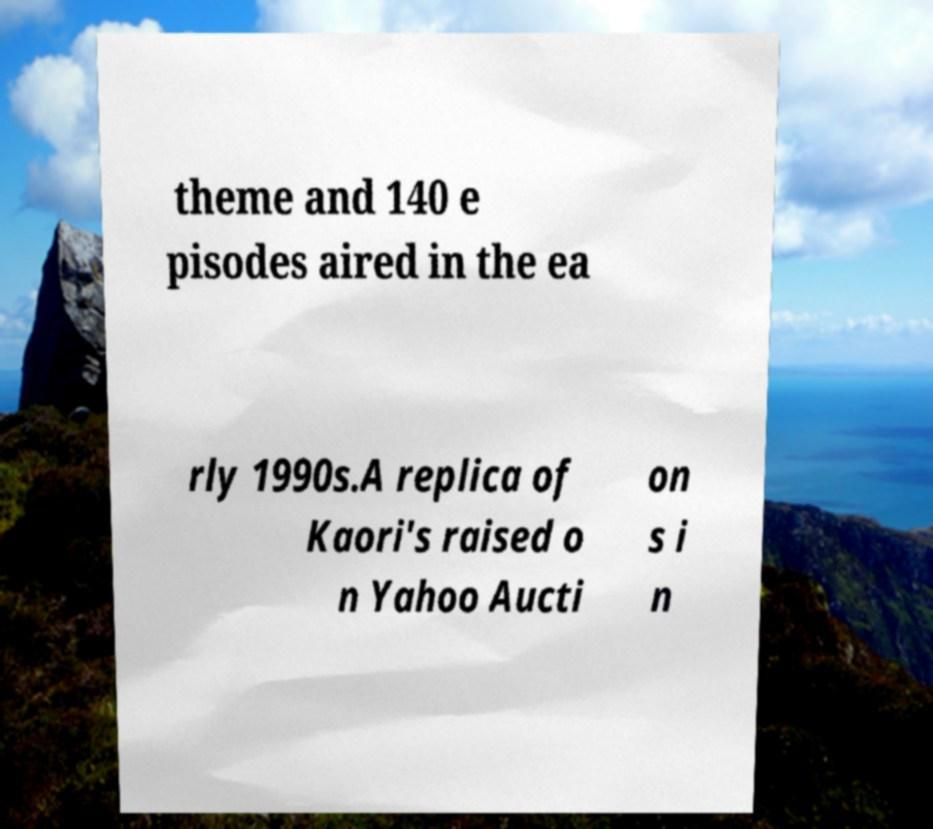Please identify and transcribe the text found in this image. theme and 140 e pisodes aired in the ea rly 1990s.A replica of Kaori's raised o n Yahoo Aucti on s i n 